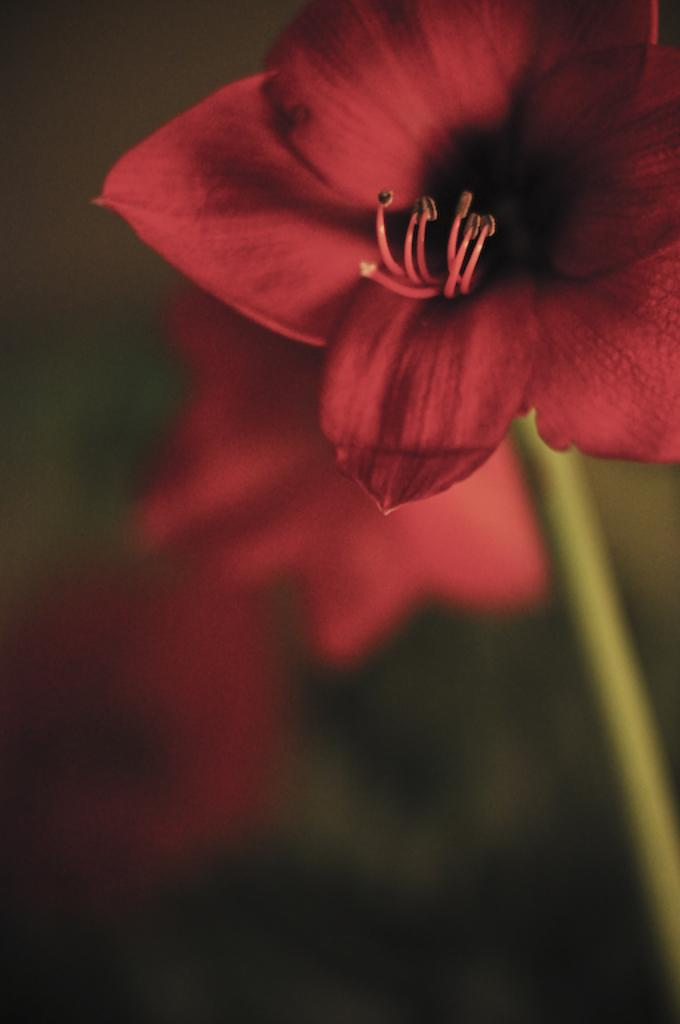What type of flower is in the image? There is a red color flower in the image. What part of the flower connects it to the plant? The flower has a stem. What can be seen in the background of the image? There are flowers and greenery in the background of the image. What type of noise is the flower making in the image? Flowers do not make noise, so there is no noise present in the image. 